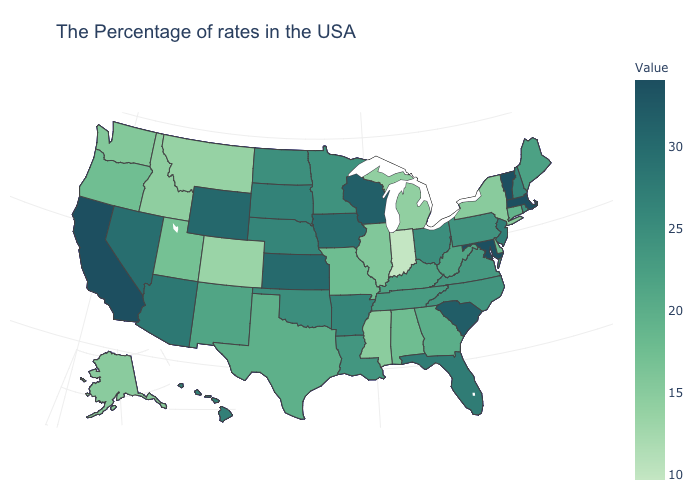Which states have the highest value in the USA?
Concise answer only. Massachusetts, Vermont, Maryland, California. Does Mississippi have the highest value in the USA?
Be succinct. No. Does Virginia have a higher value than Indiana?
Quick response, please. Yes. Among the states that border Nebraska , which have the lowest value?
Write a very short answer. Colorado. Does the map have missing data?
Concise answer only. No. Does Michigan have the highest value in the USA?
Answer briefly. No. 